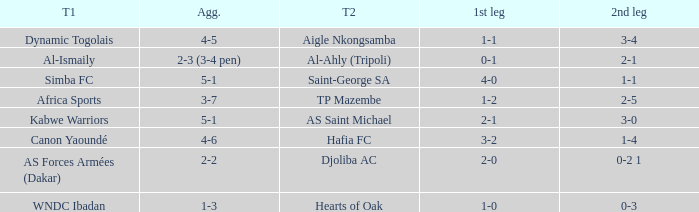When Kabwe Warriors (team 1) played, what was the result of the 1st leg? 2-1. 